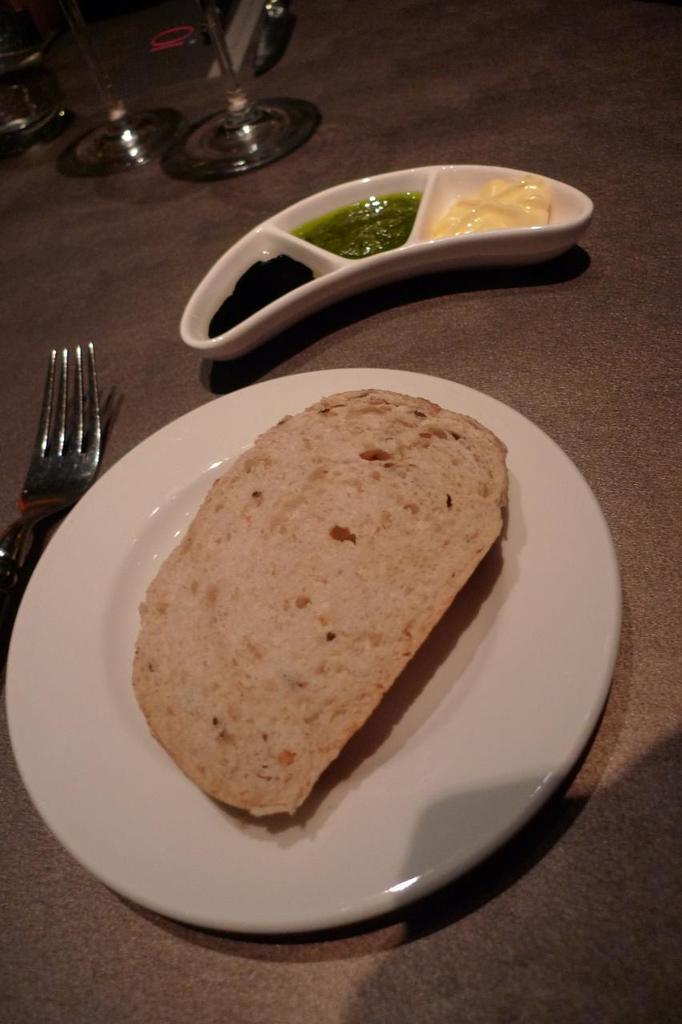Please provide a concise description of this image. In this image there are plates, glasses and a fork on the table. There is food on the plates. There are sauces and a bread on the plate. 